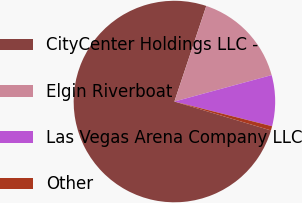Convert chart. <chart><loc_0><loc_0><loc_500><loc_500><pie_chart><fcel>CityCenter Holdings LLC -<fcel>Elgin Riverboat<fcel>Las Vegas Arena Company LLC<fcel>Other<nl><fcel>75.5%<fcel>15.65%<fcel>8.17%<fcel>0.69%<nl></chart> 